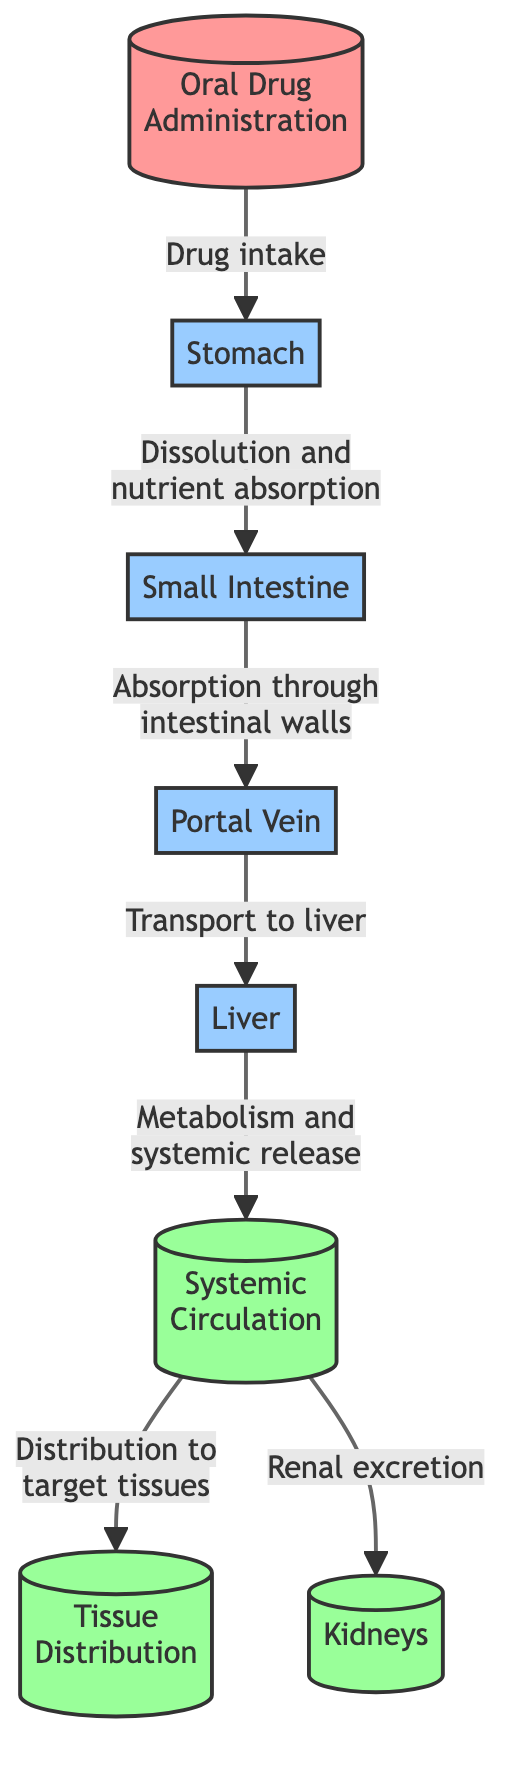What is the first step in the drug absorption process? The diagram shows that the first step in the drug absorption process is "Oral Drug Administration", where the drug is taken orally to begin the absorption pathway.
Answer: Oral Drug Administration How many major nodes are there in the diagram? By counting all the distinct nodes in the flow of the diagram, we find there are a total of eight nodes that represent different stages of the drug absorption and distribution process.
Answer: 8 What is the output pathway following systemic circulation? The diagram indicates two output pathways: "Tissue Distribution" and "Renal excretion", which are the pathways resulting from systemic circulation.
Answer: Tissue Distribution, Renal excretion Which organ is responsible for the metabolism of the drug? Following the flow of the diagram, the "Liver" is identified as the organ responsible for metabolizing the drug after its transport via the portal vein.
Answer: Liver What process occurs in the small intestine? The diagram describes the small intestine as the stage where "Absorption through intestinal walls" takes place, signifying a critical phase in the drug absorption process.
Answer: Absorption through intestinal walls What is the second step in the drug absorption process? The second step following oral drug administration is "Stomach", where the drug undergoes dissolution and nutrient absorption before moving to the small intestine.
Answer: Stomach What happens after the drug is absorbed through the intestinal walls? After absorption through the intestinal walls, the drug is transported via the "Portal Vein" to the liver, as shown in the diagram's flow sequence.
Answer: Transport to liver What are the two outputs of systemic circulation? According to the diagram, the two outputs of systemic circulation are "Tissue Distribution" and "Renal excretion," which indicate where the drug goes after entering the systemic circulation.
Answer: Tissue Distribution, Renal excretion What pathway does the drug take after leaving the liver? The drug, upon leaving the liver, enters "Systemic Circulation," which is the next significant step in its pathway according to the diagram.
Answer: Systemic Circulation 